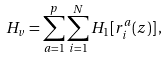<formula> <loc_0><loc_0><loc_500><loc_500>H _ { v } = \sum _ { a = 1 } ^ { p } \sum _ { i = 1 } ^ { N } H _ { 1 } [ { r } _ { i } ^ { a } ( z ) ] \, ,</formula> 